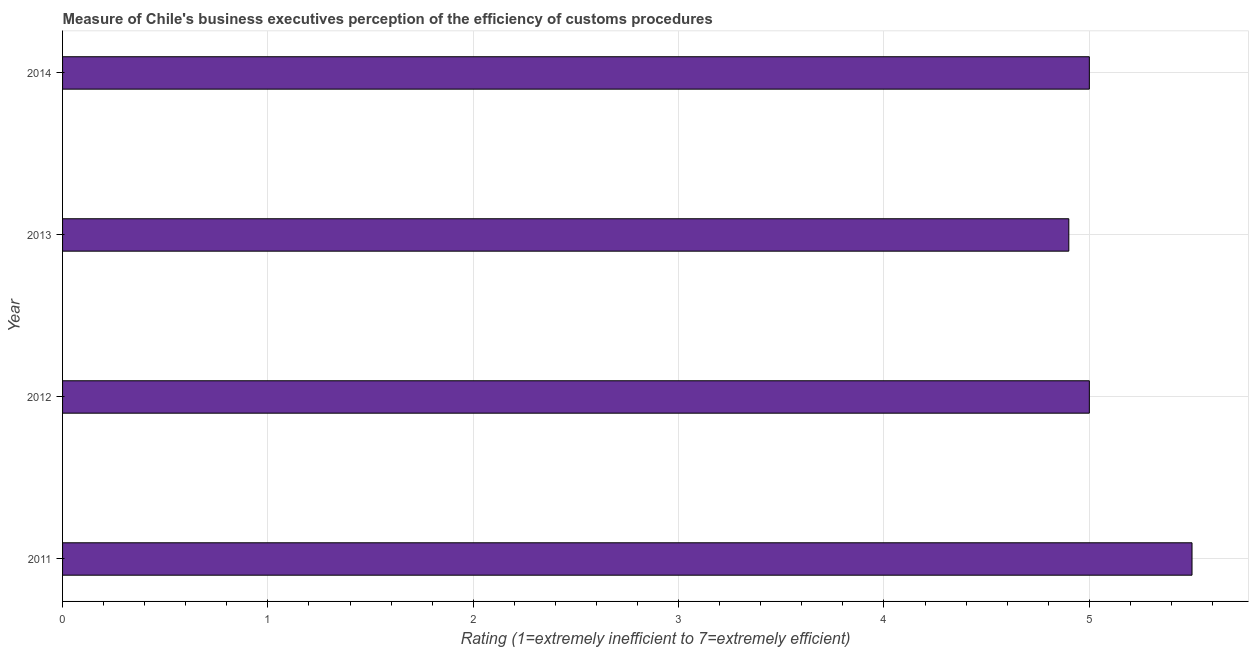Does the graph contain any zero values?
Your response must be concise. No. What is the title of the graph?
Keep it short and to the point. Measure of Chile's business executives perception of the efficiency of customs procedures. What is the label or title of the X-axis?
Provide a short and direct response. Rating (1=extremely inefficient to 7=extremely efficient). What is the label or title of the Y-axis?
Your response must be concise. Year. Across all years, what is the maximum rating measuring burden of customs procedure?
Give a very brief answer. 5.5. Across all years, what is the minimum rating measuring burden of customs procedure?
Offer a very short reply. 4.9. What is the sum of the rating measuring burden of customs procedure?
Your answer should be compact. 20.4. What is the average rating measuring burden of customs procedure per year?
Provide a short and direct response. 5.1. What is the ratio of the rating measuring burden of customs procedure in 2011 to that in 2012?
Keep it short and to the point. 1.1. What is the difference between the highest and the lowest rating measuring burden of customs procedure?
Offer a very short reply. 0.6. In how many years, is the rating measuring burden of customs procedure greater than the average rating measuring burden of customs procedure taken over all years?
Provide a succinct answer. 1. Are all the bars in the graph horizontal?
Ensure brevity in your answer.  Yes. Are the values on the major ticks of X-axis written in scientific E-notation?
Offer a very short reply. No. What is the Rating (1=extremely inefficient to 7=extremely efficient) in 2012?
Your response must be concise. 5. What is the Rating (1=extremely inefficient to 7=extremely efficient) of 2013?
Provide a succinct answer. 4.9. What is the difference between the Rating (1=extremely inefficient to 7=extremely efficient) in 2011 and 2013?
Give a very brief answer. 0.6. What is the difference between the Rating (1=extremely inefficient to 7=extremely efficient) in 2012 and 2014?
Ensure brevity in your answer.  0. What is the ratio of the Rating (1=extremely inefficient to 7=extremely efficient) in 2011 to that in 2012?
Offer a terse response. 1.1. What is the ratio of the Rating (1=extremely inefficient to 7=extremely efficient) in 2011 to that in 2013?
Keep it short and to the point. 1.12. What is the ratio of the Rating (1=extremely inefficient to 7=extremely efficient) in 2011 to that in 2014?
Offer a very short reply. 1.1. What is the ratio of the Rating (1=extremely inefficient to 7=extremely efficient) in 2012 to that in 2013?
Give a very brief answer. 1.02. What is the ratio of the Rating (1=extremely inefficient to 7=extremely efficient) in 2012 to that in 2014?
Make the answer very short. 1. 